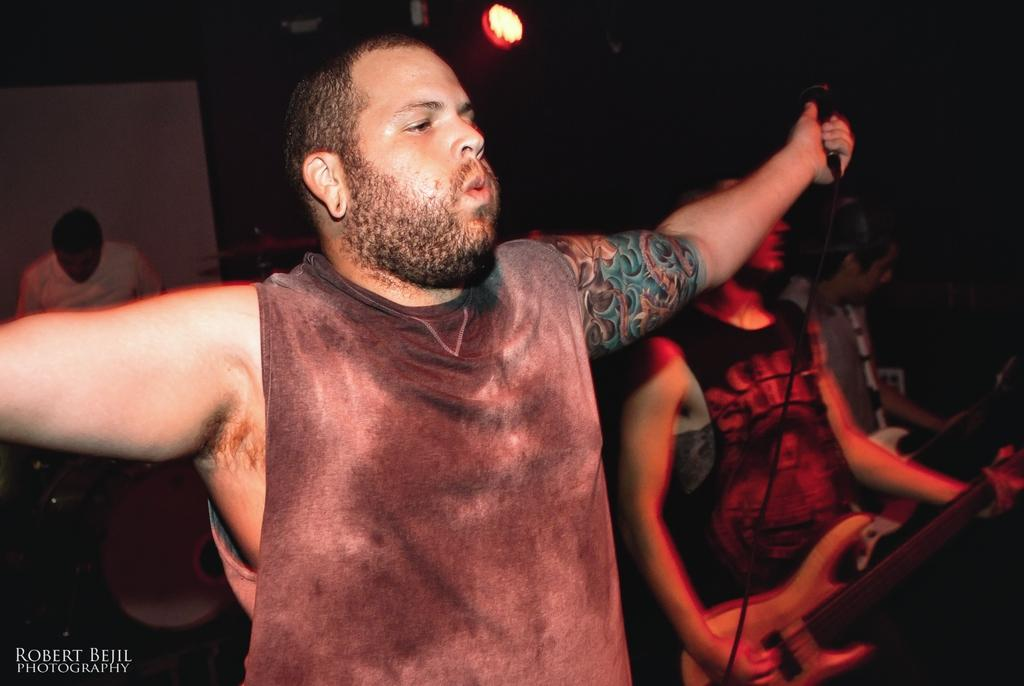What is the man in the image doing? The man is standing in the image and holding a microphone in his left hand. What instrument is being played by another person in the image? There is a person playing a guitar in the image. Where is the guitar-playing person located in relation to the man with the microphone? The guitar-playing person is on the right side of the image. What type of oven can be seen in the background of the image? There is no oven present in the image. Is there any blood visible on the guitar-playing person in the image? There is no blood visible on the guitar-playing person in the image. 